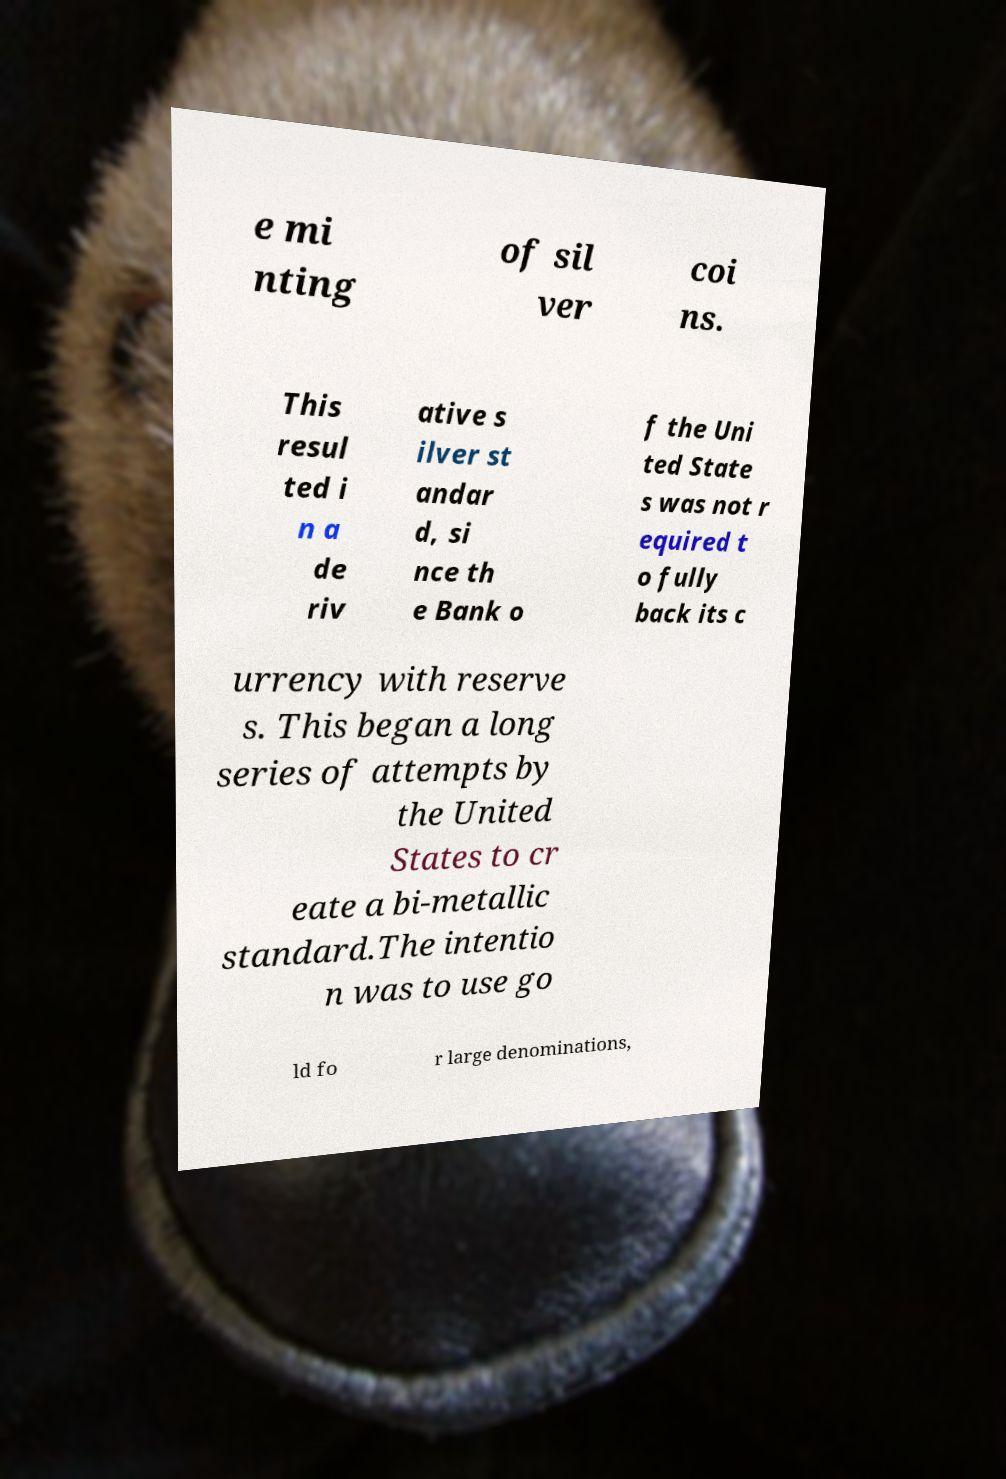Could you extract and type out the text from this image? e mi nting of sil ver coi ns. This resul ted i n a de riv ative s ilver st andar d, si nce th e Bank o f the Uni ted State s was not r equired t o fully back its c urrency with reserve s. This began a long series of attempts by the United States to cr eate a bi-metallic standard.The intentio n was to use go ld fo r large denominations, 